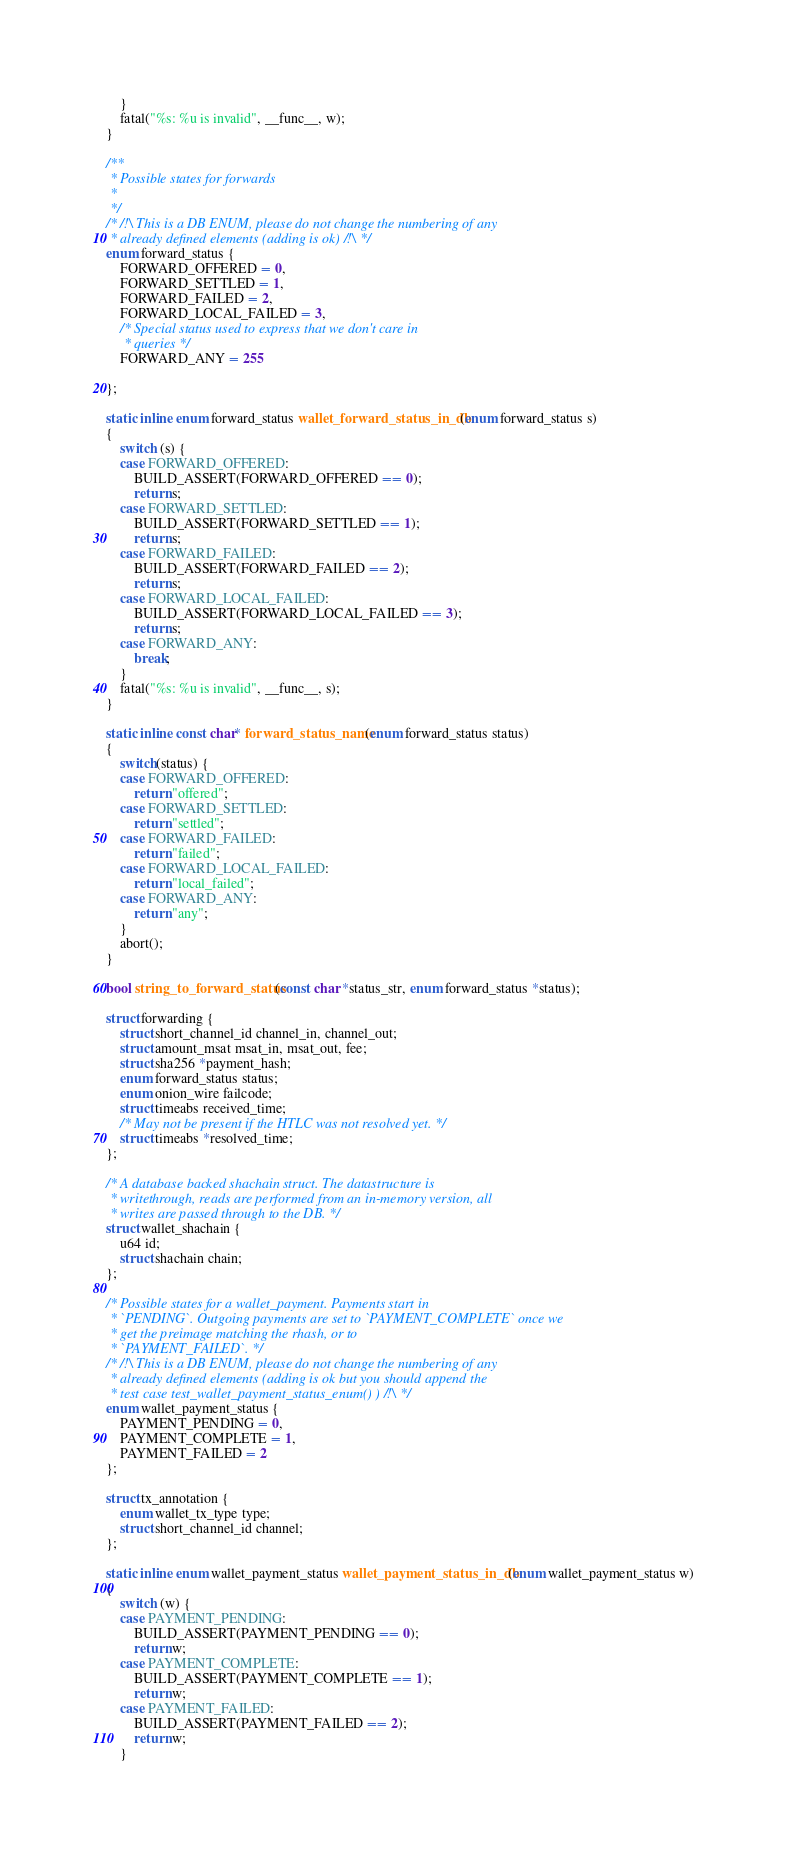Convert code to text. <code><loc_0><loc_0><loc_500><loc_500><_C_>	}
	fatal("%s: %u is invalid", __func__, w);
}

/**
 * Possible states for forwards
 *
 */
/* /!\ This is a DB ENUM, please do not change the numbering of any
 * already defined elements (adding is ok) /!\ */
enum forward_status {
	FORWARD_OFFERED = 0,
	FORWARD_SETTLED = 1,
	FORWARD_FAILED = 2,
	FORWARD_LOCAL_FAILED = 3,
	/* Special status used to express that we don't care in
	 * queries */
	FORWARD_ANY = 255

};

static inline enum forward_status wallet_forward_status_in_db(enum forward_status s)
{
	switch (s) {
	case FORWARD_OFFERED:
		BUILD_ASSERT(FORWARD_OFFERED == 0);
		return s;
	case FORWARD_SETTLED:
		BUILD_ASSERT(FORWARD_SETTLED == 1);
		return s;
	case FORWARD_FAILED:
		BUILD_ASSERT(FORWARD_FAILED == 2);
		return s;
	case FORWARD_LOCAL_FAILED:
		BUILD_ASSERT(FORWARD_LOCAL_FAILED == 3);
		return s;
	case FORWARD_ANY:
		break;
	}
	fatal("%s: %u is invalid", __func__, s);
}

static inline const char* forward_status_name(enum forward_status status)
{
	switch(status) {
	case FORWARD_OFFERED:
		return "offered";
	case FORWARD_SETTLED:
		return "settled";
	case FORWARD_FAILED:
		return "failed";
	case FORWARD_LOCAL_FAILED:
		return "local_failed";
	case FORWARD_ANY:
		return "any";
	}
	abort();
}

bool string_to_forward_status(const char *status_str, enum forward_status *status);

struct forwarding {
	struct short_channel_id channel_in, channel_out;
	struct amount_msat msat_in, msat_out, fee;
	struct sha256 *payment_hash;
	enum forward_status status;
	enum onion_wire failcode;
	struct timeabs received_time;
	/* May not be present if the HTLC was not resolved yet. */
	struct timeabs *resolved_time;
};

/* A database backed shachain struct. The datastructure is
 * writethrough, reads are performed from an in-memory version, all
 * writes are passed through to the DB. */
struct wallet_shachain {
	u64 id;
	struct shachain chain;
};

/* Possible states for a wallet_payment. Payments start in
 * `PENDING`. Outgoing payments are set to `PAYMENT_COMPLETE` once we
 * get the preimage matching the rhash, or to
 * `PAYMENT_FAILED`. */
/* /!\ This is a DB ENUM, please do not change the numbering of any
 * already defined elements (adding is ok but you should append the
 * test case test_wallet_payment_status_enum() ) /!\ */
enum wallet_payment_status {
	PAYMENT_PENDING = 0,
	PAYMENT_COMPLETE = 1,
	PAYMENT_FAILED = 2
};

struct tx_annotation {
	enum wallet_tx_type type;
	struct short_channel_id channel;
};

static inline enum wallet_payment_status wallet_payment_status_in_db(enum wallet_payment_status w)
{
	switch (w) {
	case PAYMENT_PENDING:
		BUILD_ASSERT(PAYMENT_PENDING == 0);
		return w;
	case PAYMENT_COMPLETE:
		BUILD_ASSERT(PAYMENT_COMPLETE == 1);
		return w;
	case PAYMENT_FAILED:
		BUILD_ASSERT(PAYMENT_FAILED == 2);
		return w;
	}</code> 